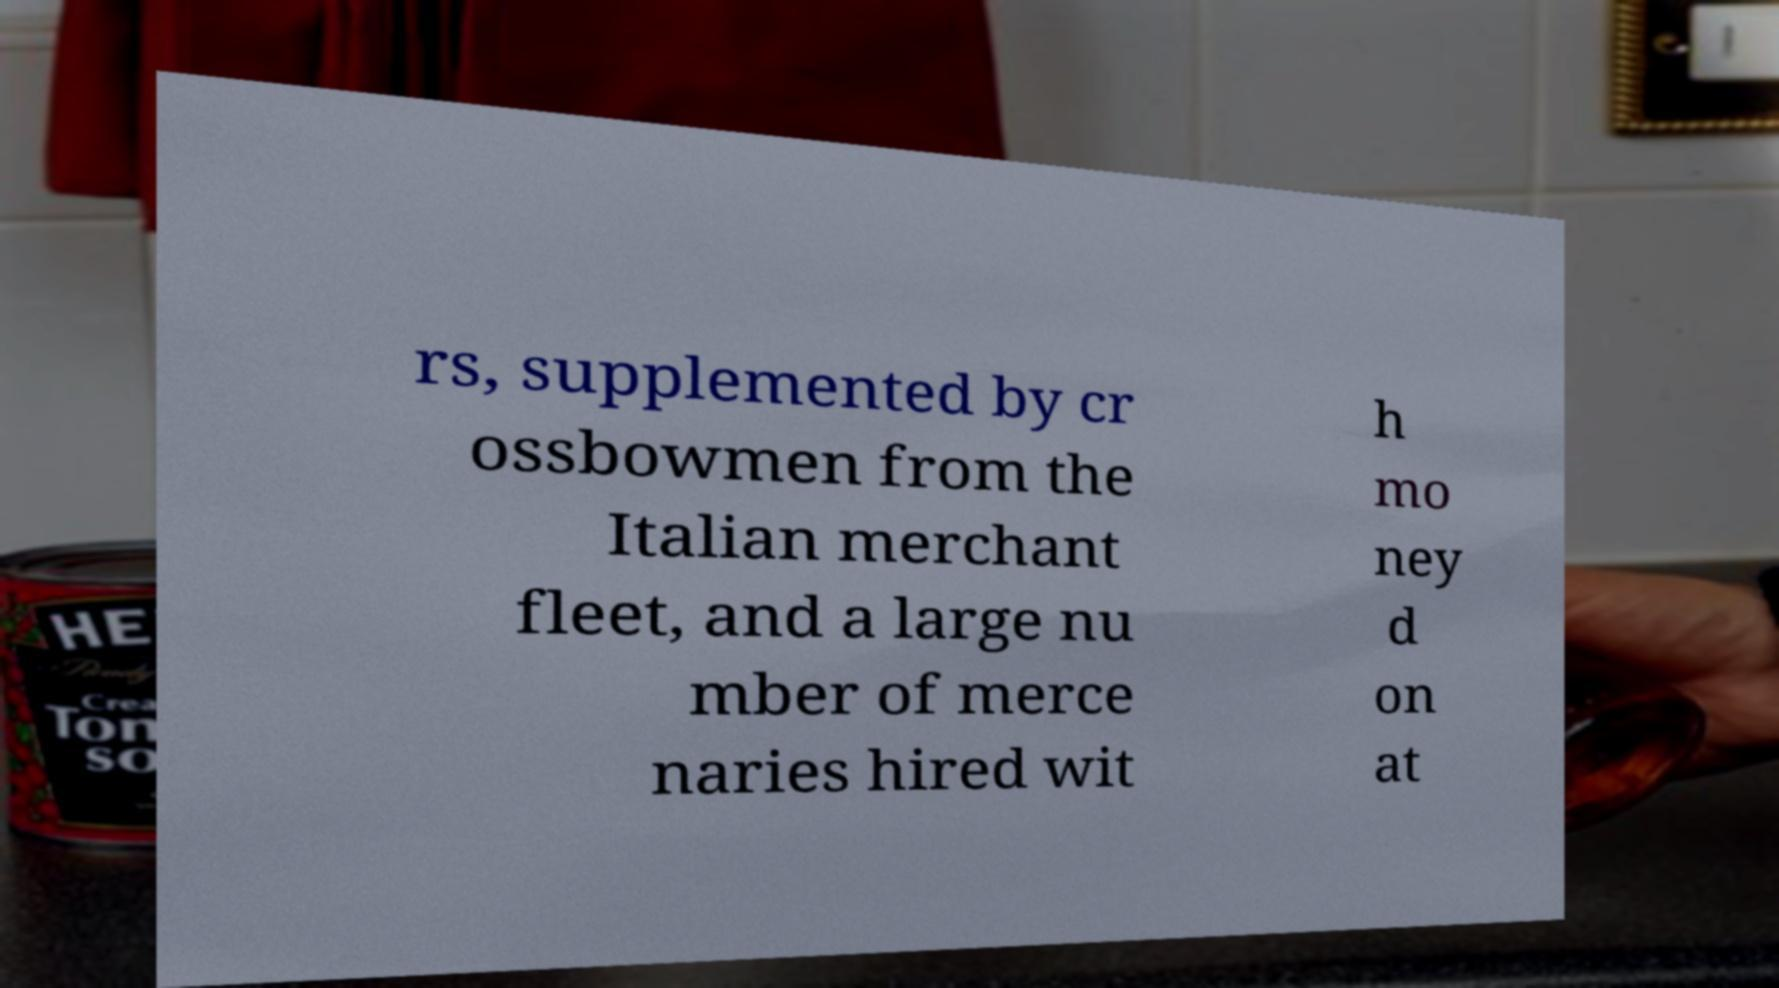For documentation purposes, I need the text within this image transcribed. Could you provide that? rs, supplemented by cr ossbowmen from the Italian merchant fleet, and a large nu mber of merce naries hired wit h mo ney d on at 